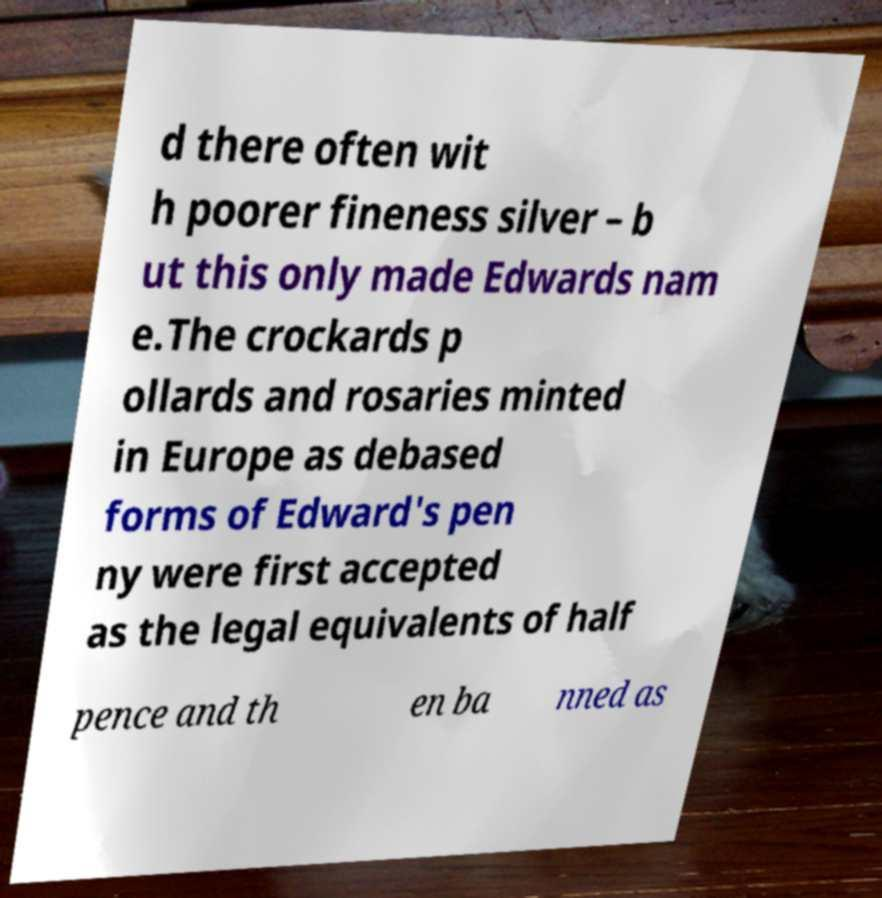Could you assist in decoding the text presented in this image and type it out clearly? d there often wit h poorer fineness silver – b ut this only made Edwards nam e.The crockards p ollards and rosaries minted in Europe as debased forms of Edward's pen ny were first accepted as the legal equivalents of half pence and th en ba nned as 